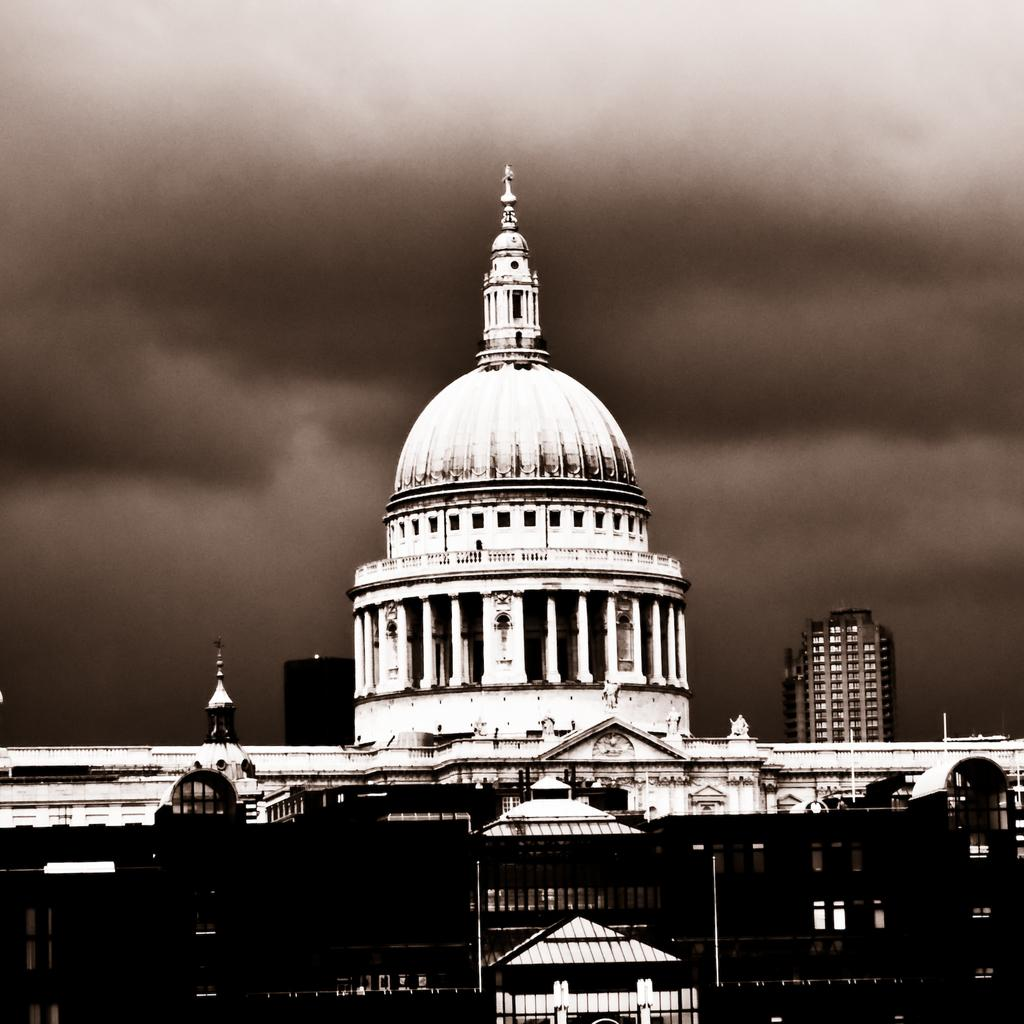What structures are present in the image? There are buildings in the image. What can be seen in the background of the image? The sky with clouds is visible in the background of the image. Can you see a railway in the image? There is no railway present in the image. How many zebras can be seen in the image? There are no zebras present in the image. 